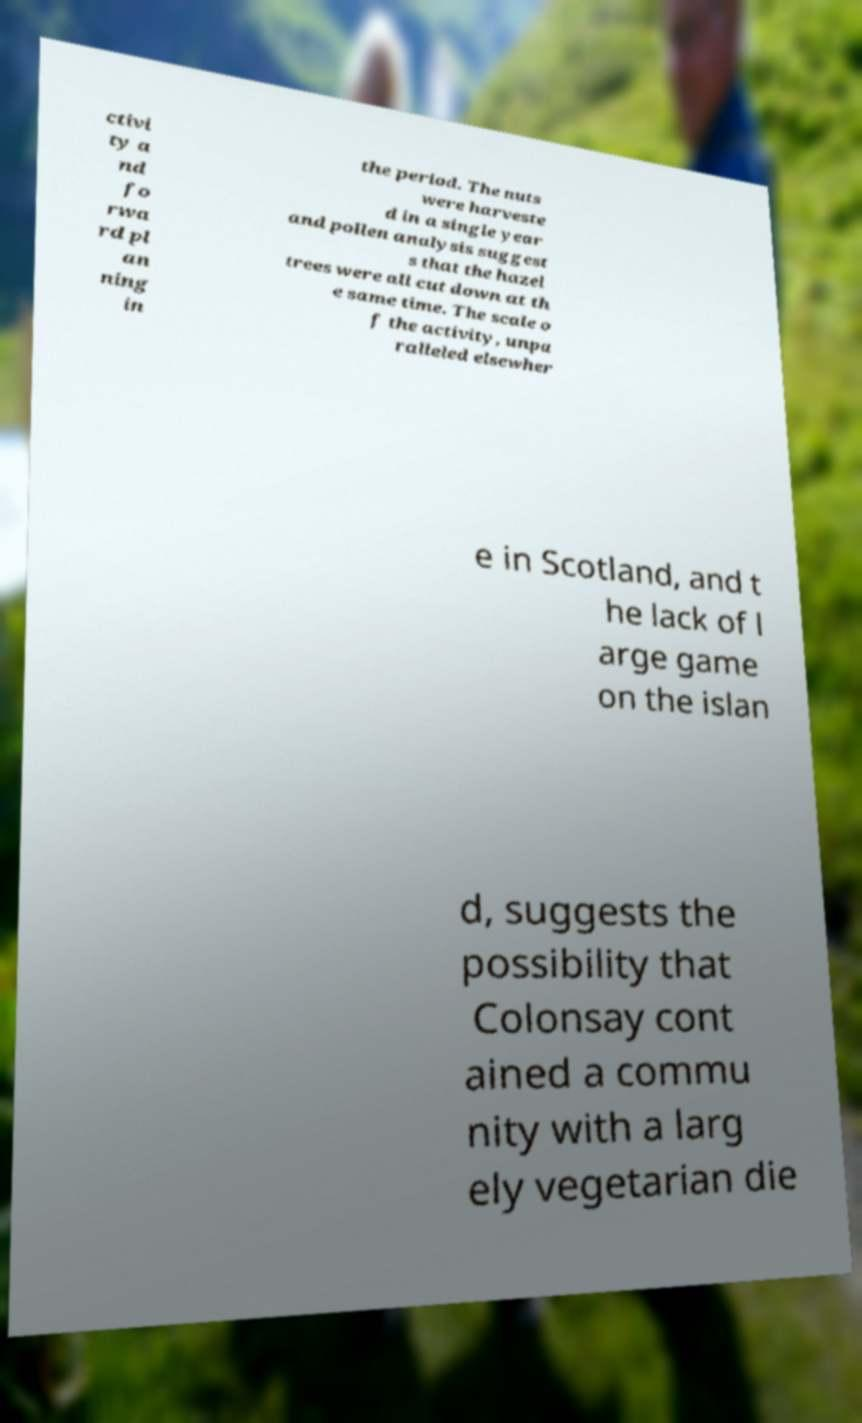Could you assist in decoding the text presented in this image and type it out clearly? ctivi ty a nd fo rwa rd pl an ning in the period. The nuts were harveste d in a single year and pollen analysis suggest s that the hazel trees were all cut down at th e same time. The scale o f the activity, unpa ralleled elsewher e in Scotland, and t he lack of l arge game on the islan d, suggests the possibility that Colonsay cont ained a commu nity with a larg ely vegetarian die 